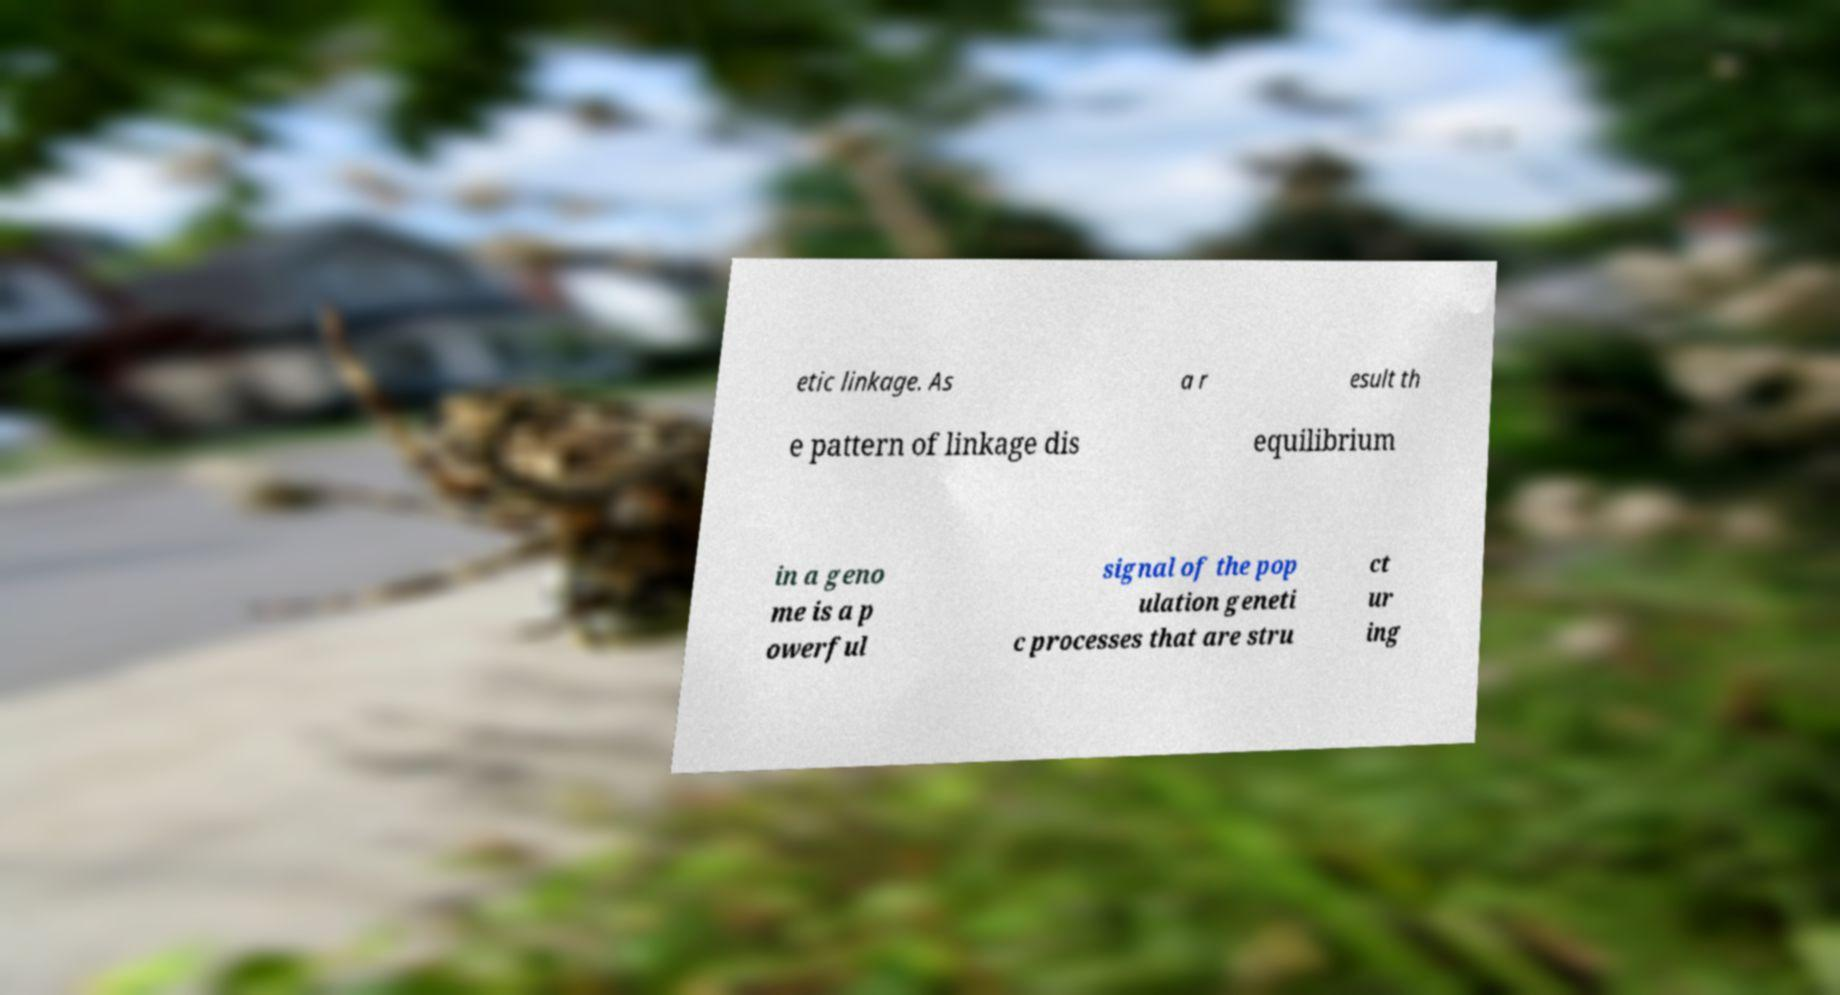Please read and relay the text visible in this image. What does it say? etic linkage. As a r esult th e pattern of linkage dis equilibrium in a geno me is a p owerful signal of the pop ulation geneti c processes that are stru ct ur ing 